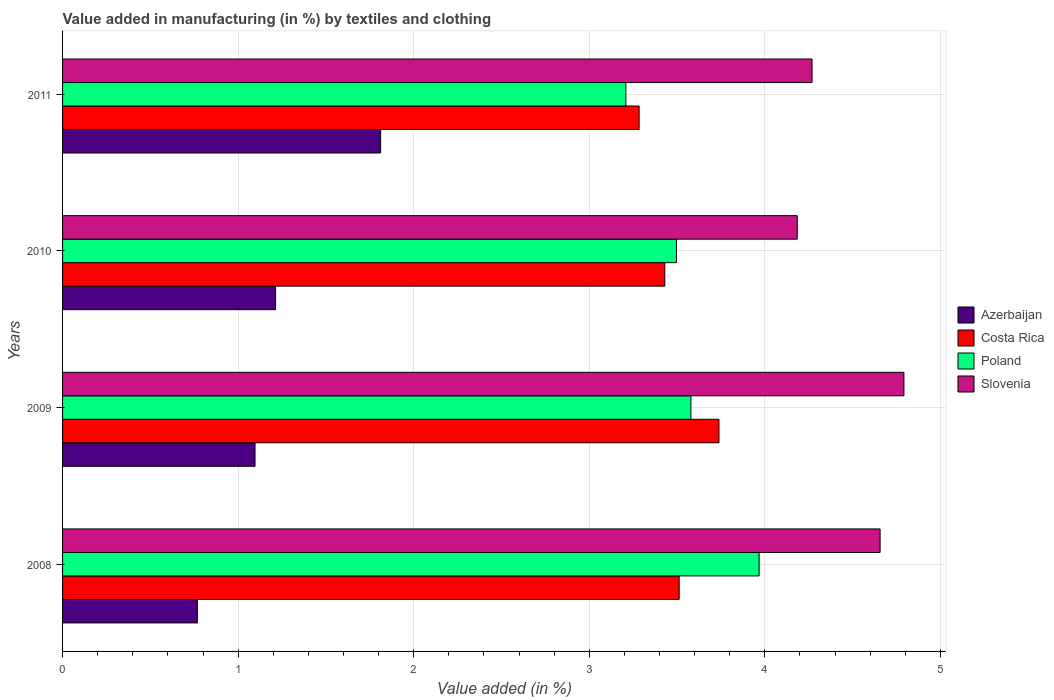How many different coloured bars are there?
Keep it short and to the point. 4. How many groups of bars are there?
Ensure brevity in your answer.  4. Are the number of bars on each tick of the Y-axis equal?
Provide a succinct answer. Yes. How many bars are there on the 4th tick from the bottom?
Offer a terse response. 4. What is the percentage of value added in manufacturing by textiles and clothing in Poland in 2008?
Your answer should be compact. 3.97. Across all years, what is the maximum percentage of value added in manufacturing by textiles and clothing in Costa Rica?
Your answer should be very brief. 3.74. Across all years, what is the minimum percentage of value added in manufacturing by textiles and clothing in Azerbaijan?
Your answer should be compact. 0.77. What is the total percentage of value added in manufacturing by textiles and clothing in Slovenia in the graph?
Provide a short and direct response. 17.9. What is the difference between the percentage of value added in manufacturing by textiles and clothing in Slovenia in 2009 and that in 2010?
Provide a succinct answer. 0.61. What is the difference between the percentage of value added in manufacturing by textiles and clothing in Slovenia in 2010 and the percentage of value added in manufacturing by textiles and clothing in Poland in 2009?
Provide a succinct answer. 0.61. What is the average percentage of value added in manufacturing by textiles and clothing in Costa Rica per year?
Offer a terse response. 3.49. In the year 2009, what is the difference between the percentage of value added in manufacturing by textiles and clothing in Costa Rica and percentage of value added in manufacturing by textiles and clothing in Azerbaijan?
Your answer should be very brief. 2.64. In how many years, is the percentage of value added in manufacturing by textiles and clothing in Slovenia greater than 1.4 %?
Make the answer very short. 4. What is the ratio of the percentage of value added in manufacturing by textiles and clothing in Poland in 2008 to that in 2010?
Offer a terse response. 1.13. What is the difference between the highest and the second highest percentage of value added in manufacturing by textiles and clothing in Slovenia?
Your answer should be compact. 0.14. What is the difference between the highest and the lowest percentage of value added in manufacturing by textiles and clothing in Costa Rica?
Keep it short and to the point. 0.45. Is the sum of the percentage of value added in manufacturing by textiles and clothing in Slovenia in 2009 and 2010 greater than the maximum percentage of value added in manufacturing by textiles and clothing in Costa Rica across all years?
Keep it short and to the point. Yes. Is it the case that in every year, the sum of the percentage of value added in manufacturing by textiles and clothing in Costa Rica and percentage of value added in manufacturing by textiles and clothing in Poland is greater than the sum of percentage of value added in manufacturing by textiles and clothing in Azerbaijan and percentage of value added in manufacturing by textiles and clothing in Slovenia?
Give a very brief answer. Yes. What does the 3rd bar from the top in 2008 represents?
Your answer should be very brief. Costa Rica. What does the 3rd bar from the bottom in 2010 represents?
Provide a short and direct response. Poland. How many years are there in the graph?
Make the answer very short. 4. Does the graph contain grids?
Provide a short and direct response. Yes. How are the legend labels stacked?
Make the answer very short. Vertical. What is the title of the graph?
Offer a very short reply. Value added in manufacturing (in %) by textiles and clothing. Does "Heavily indebted poor countries" appear as one of the legend labels in the graph?
Ensure brevity in your answer.  No. What is the label or title of the X-axis?
Make the answer very short. Value added (in %). What is the label or title of the Y-axis?
Give a very brief answer. Years. What is the Value added (in %) in Azerbaijan in 2008?
Provide a succinct answer. 0.77. What is the Value added (in %) in Costa Rica in 2008?
Your answer should be very brief. 3.51. What is the Value added (in %) in Poland in 2008?
Make the answer very short. 3.97. What is the Value added (in %) of Slovenia in 2008?
Provide a short and direct response. 4.66. What is the Value added (in %) of Azerbaijan in 2009?
Ensure brevity in your answer.  1.1. What is the Value added (in %) in Costa Rica in 2009?
Offer a terse response. 3.74. What is the Value added (in %) of Poland in 2009?
Offer a very short reply. 3.58. What is the Value added (in %) in Slovenia in 2009?
Your answer should be very brief. 4.79. What is the Value added (in %) in Azerbaijan in 2010?
Offer a terse response. 1.21. What is the Value added (in %) of Costa Rica in 2010?
Provide a short and direct response. 3.43. What is the Value added (in %) of Poland in 2010?
Make the answer very short. 3.5. What is the Value added (in %) in Slovenia in 2010?
Provide a succinct answer. 4.18. What is the Value added (in %) of Azerbaijan in 2011?
Make the answer very short. 1.81. What is the Value added (in %) of Costa Rica in 2011?
Make the answer very short. 3.28. What is the Value added (in %) of Poland in 2011?
Offer a very short reply. 3.21. What is the Value added (in %) in Slovenia in 2011?
Keep it short and to the point. 4.27. Across all years, what is the maximum Value added (in %) in Azerbaijan?
Offer a very short reply. 1.81. Across all years, what is the maximum Value added (in %) in Costa Rica?
Your response must be concise. 3.74. Across all years, what is the maximum Value added (in %) in Poland?
Keep it short and to the point. 3.97. Across all years, what is the maximum Value added (in %) of Slovenia?
Provide a succinct answer. 4.79. Across all years, what is the minimum Value added (in %) in Azerbaijan?
Offer a terse response. 0.77. Across all years, what is the minimum Value added (in %) in Costa Rica?
Provide a succinct answer. 3.28. Across all years, what is the minimum Value added (in %) of Poland?
Provide a short and direct response. 3.21. Across all years, what is the minimum Value added (in %) of Slovenia?
Ensure brevity in your answer.  4.18. What is the total Value added (in %) of Azerbaijan in the graph?
Make the answer very short. 4.89. What is the total Value added (in %) of Costa Rica in the graph?
Keep it short and to the point. 13.97. What is the total Value added (in %) of Poland in the graph?
Give a very brief answer. 14.25. What is the total Value added (in %) in Slovenia in the graph?
Offer a terse response. 17.9. What is the difference between the Value added (in %) in Azerbaijan in 2008 and that in 2009?
Keep it short and to the point. -0.33. What is the difference between the Value added (in %) of Costa Rica in 2008 and that in 2009?
Provide a succinct answer. -0.23. What is the difference between the Value added (in %) in Poland in 2008 and that in 2009?
Offer a very short reply. 0.39. What is the difference between the Value added (in %) of Slovenia in 2008 and that in 2009?
Ensure brevity in your answer.  -0.14. What is the difference between the Value added (in %) in Azerbaijan in 2008 and that in 2010?
Give a very brief answer. -0.45. What is the difference between the Value added (in %) of Costa Rica in 2008 and that in 2010?
Give a very brief answer. 0.08. What is the difference between the Value added (in %) of Poland in 2008 and that in 2010?
Provide a short and direct response. 0.47. What is the difference between the Value added (in %) in Slovenia in 2008 and that in 2010?
Provide a short and direct response. 0.47. What is the difference between the Value added (in %) in Azerbaijan in 2008 and that in 2011?
Ensure brevity in your answer.  -1.04. What is the difference between the Value added (in %) in Costa Rica in 2008 and that in 2011?
Give a very brief answer. 0.23. What is the difference between the Value added (in %) in Poland in 2008 and that in 2011?
Your response must be concise. 0.76. What is the difference between the Value added (in %) in Slovenia in 2008 and that in 2011?
Provide a short and direct response. 0.39. What is the difference between the Value added (in %) in Azerbaijan in 2009 and that in 2010?
Provide a succinct answer. -0.12. What is the difference between the Value added (in %) in Costa Rica in 2009 and that in 2010?
Offer a terse response. 0.31. What is the difference between the Value added (in %) of Poland in 2009 and that in 2010?
Make the answer very short. 0.08. What is the difference between the Value added (in %) in Slovenia in 2009 and that in 2010?
Provide a succinct answer. 0.61. What is the difference between the Value added (in %) in Azerbaijan in 2009 and that in 2011?
Your answer should be compact. -0.72. What is the difference between the Value added (in %) in Costa Rica in 2009 and that in 2011?
Offer a terse response. 0.45. What is the difference between the Value added (in %) in Poland in 2009 and that in 2011?
Keep it short and to the point. 0.37. What is the difference between the Value added (in %) of Slovenia in 2009 and that in 2011?
Offer a very short reply. 0.52. What is the difference between the Value added (in %) of Azerbaijan in 2010 and that in 2011?
Offer a very short reply. -0.6. What is the difference between the Value added (in %) of Costa Rica in 2010 and that in 2011?
Keep it short and to the point. 0.15. What is the difference between the Value added (in %) in Poland in 2010 and that in 2011?
Provide a short and direct response. 0.29. What is the difference between the Value added (in %) of Slovenia in 2010 and that in 2011?
Your answer should be very brief. -0.08. What is the difference between the Value added (in %) of Azerbaijan in 2008 and the Value added (in %) of Costa Rica in 2009?
Your answer should be compact. -2.97. What is the difference between the Value added (in %) in Azerbaijan in 2008 and the Value added (in %) in Poland in 2009?
Make the answer very short. -2.81. What is the difference between the Value added (in %) of Azerbaijan in 2008 and the Value added (in %) of Slovenia in 2009?
Make the answer very short. -4.02. What is the difference between the Value added (in %) of Costa Rica in 2008 and the Value added (in %) of Poland in 2009?
Ensure brevity in your answer.  -0.07. What is the difference between the Value added (in %) in Costa Rica in 2008 and the Value added (in %) in Slovenia in 2009?
Provide a succinct answer. -1.28. What is the difference between the Value added (in %) in Poland in 2008 and the Value added (in %) in Slovenia in 2009?
Your answer should be compact. -0.82. What is the difference between the Value added (in %) in Azerbaijan in 2008 and the Value added (in %) in Costa Rica in 2010?
Keep it short and to the point. -2.66. What is the difference between the Value added (in %) in Azerbaijan in 2008 and the Value added (in %) in Poland in 2010?
Keep it short and to the point. -2.73. What is the difference between the Value added (in %) in Azerbaijan in 2008 and the Value added (in %) in Slovenia in 2010?
Give a very brief answer. -3.42. What is the difference between the Value added (in %) of Costa Rica in 2008 and the Value added (in %) of Poland in 2010?
Make the answer very short. 0.02. What is the difference between the Value added (in %) of Costa Rica in 2008 and the Value added (in %) of Slovenia in 2010?
Offer a very short reply. -0.67. What is the difference between the Value added (in %) of Poland in 2008 and the Value added (in %) of Slovenia in 2010?
Provide a short and direct response. -0.22. What is the difference between the Value added (in %) in Azerbaijan in 2008 and the Value added (in %) in Costa Rica in 2011?
Keep it short and to the point. -2.52. What is the difference between the Value added (in %) in Azerbaijan in 2008 and the Value added (in %) in Poland in 2011?
Your answer should be very brief. -2.44. What is the difference between the Value added (in %) of Azerbaijan in 2008 and the Value added (in %) of Slovenia in 2011?
Your response must be concise. -3.5. What is the difference between the Value added (in %) in Costa Rica in 2008 and the Value added (in %) in Poland in 2011?
Give a very brief answer. 0.3. What is the difference between the Value added (in %) of Costa Rica in 2008 and the Value added (in %) of Slovenia in 2011?
Provide a succinct answer. -0.76. What is the difference between the Value added (in %) in Poland in 2008 and the Value added (in %) in Slovenia in 2011?
Keep it short and to the point. -0.3. What is the difference between the Value added (in %) of Azerbaijan in 2009 and the Value added (in %) of Costa Rica in 2010?
Keep it short and to the point. -2.33. What is the difference between the Value added (in %) of Azerbaijan in 2009 and the Value added (in %) of Poland in 2010?
Give a very brief answer. -2.4. What is the difference between the Value added (in %) in Azerbaijan in 2009 and the Value added (in %) in Slovenia in 2010?
Offer a very short reply. -3.09. What is the difference between the Value added (in %) in Costa Rica in 2009 and the Value added (in %) in Poland in 2010?
Provide a short and direct response. 0.24. What is the difference between the Value added (in %) in Costa Rica in 2009 and the Value added (in %) in Slovenia in 2010?
Provide a succinct answer. -0.45. What is the difference between the Value added (in %) in Poland in 2009 and the Value added (in %) in Slovenia in 2010?
Give a very brief answer. -0.61. What is the difference between the Value added (in %) in Azerbaijan in 2009 and the Value added (in %) in Costa Rica in 2011?
Keep it short and to the point. -2.19. What is the difference between the Value added (in %) of Azerbaijan in 2009 and the Value added (in %) of Poland in 2011?
Offer a terse response. -2.11. What is the difference between the Value added (in %) in Azerbaijan in 2009 and the Value added (in %) in Slovenia in 2011?
Provide a succinct answer. -3.17. What is the difference between the Value added (in %) in Costa Rica in 2009 and the Value added (in %) in Poland in 2011?
Your response must be concise. 0.53. What is the difference between the Value added (in %) in Costa Rica in 2009 and the Value added (in %) in Slovenia in 2011?
Your response must be concise. -0.53. What is the difference between the Value added (in %) in Poland in 2009 and the Value added (in %) in Slovenia in 2011?
Offer a very short reply. -0.69. What is the difference between the Value added (in %) of Azerbaijan in 2010 and the Value added (in %) of Costa Rica in 2011?
Your answer should be very brief. -2.07. What is the difference between the Value added (in %) in Azerbaijan in 2010 and the Value added (in %) in Poland in 2011?
Offer a terse response. -2. What is the difference between the Value added (in %) in Azerbaijan in 2010 and the Value added (in %) in Slovenia in 2011?
Give a very brief answer. -3.06. What is the difference between the Value added (in %) in Costa Rica in 2010 and the Value added (in %) in Poland in 2011?
Your response must be concise. 0.22. What is the difference between the Value added (in %) of Costa Rica in 2010 and the Value added (in %) of Slovenia in 2011?
Give a very brief answer. -0.84. What is the difference between the Value added (in %) in Poland in 2010 and the Value added (in %) in Slovenia in 2011?
Your response must be concise. -0.77. What is the average Value added (in %) of Azerbaijan per year?
Give a very brief answer. 1.22. What is the average Value added (in %) of Costa Rica per year?
Make the answer very short. 3.49. What is the average Value added (in %) in Poland per year?
Your response must be concise. 3.56. What is the average Value added (in %) in Slovenia per year?
Make the answer very short. 4.48. In the year 2008, what is the difference between the Value added (in %) of Azerbaijan and Value added (in %) of Costa Rica?
Give a very brief answer. -2.74. In the year 2008, what is the difference between the Value added (in %) in Azerbaijan and Value added (in %) in Poland?
Offer a terse response. -3.2. In the year 2008, what is the difference between the Value added (in %) in Azerbaijan and Value added (in %) in Slovenia?
Offer a very short reply. -3.89. In the year 2008, what is the difference between the Value added (in %) of Costa Rica and Value added (in %) of Poland?
Provide a succinct answer. -0.46. In the year 2008, what is the difference between the Value added (in %) of Costa Rica and Value added (in %) of Slovenia?
Make the answer very short. -1.14. In the year 2008, what is the difference between the Value added (in %) in Poland and Value added (in %) in Slovenia?
Give a very brief answer. -0.69. In the year 2009, what is the difference between the Value added (in %) of Azerbaijan and Value added (in %) of Costa Rica?
Ensure brevity in your answer.  -2.64. In the year 2009, what is the difference between the Value added (in %) in Azerbaijan and Value added (in %) in Poland?
Offer a very short reply. -2.48. In the year 2009, what is the difference between the Value added (in %) of Azerbaijan and Value added (in %) of Slovenia?
Your response must be concise. -3.7. In the year 2009, what is the difference between the Value added (in %) of Costa Rica and Value added (in %) of Poland?
Offer a terse response. 0.16. In the year 2009, what is the difference between the Value added (in %) in Costa Rica and Value added (in %) in Slovenia?
Provide a short and direct response. -1.05. In the year 2009, what is the difference between the Value added (in %) in Poland and Value added (in %) in Slovenia?
Keep it short and to the point. -1.21. In the year 2010, what is the difference between the Value added (in %) of Azerbaijan and Value added (in %) of Costa Rica?
Keep it short and to the point. -2.22. In the year 2010, what is the difference between the Value added (in %) of Azerbaijan and Value added (in %) of Poland?
Your answer should be very brief. -2.28. In the year 2010, what is the difference between the Value added (in %) of Azerbaijan and Value added (in %) of Slovenia?
Your answer should be very brief. -2.97. In the year 2010, what is the difference between the Value added (in %) in Costa Rica and Value added (in %) in Poland?
Your response must be concise. -0.07. In the year 2010, what is the difference between the Value added (in %) of Costa Rica and Value added (in %) of Slovenia?
Make the answer very short. -0.75. In the year 2010, what is the difference between the Value added (in %) in Poland and Value added (in %) in Slovenia?
Provide a succinct answer. -0.69. In the year 2011, what is the difference between the Value added (in %) in Azerbaijan and Value added (in %) in Costa Rica?
Your response must be concise. -1.47. In the year 2011, what is the difference between the Value added (in %) in Azerbaijan and Value added (in %) in Poland?
Keep it short and to the point. -1.4. In the year 2011, what is the difference between the Value added (in %) of Azerbaijan and Value added (in %) of Slovenia?
Offer a terse response. -2.46. In the year 2011, what is the difference between the Value added (in %) in Costa Rica and Value added (in %) in Poland?
Keep it short and to the point. 0.08. In the year 2011, what is the difference between the Value added (in %) of Costa Rica and Value added (in %) of Slovenia?
Your answer should be very brief. -0.98. In the year 2011, what is the difference between the Value added (in %) in Poland and Value added (in %) in Slovenia?
Make the answer very short. -1.06. What is the ratio of the Value added (in %) in Azerbaijan in 2008 to that in 2009?
Your response must be concise. 0.7. What is the ratio of the Value added (in %) of Costa Rica in 2008 to that in 2009?
Offer a terse response. 0.94. What is the ratio of the Value added (in %) in Poland in 2008 to that in 2009?
Make the answer very short. 1.11. What is the ratio of the Value added (in %) of Slovenia in 2008 to that in 2009?
Provide a short and direct response. 0.97. What is the ratio of the Value added (in %) of Azerbaijan in 2008 to that in 2010?
Keep it short and to the point. 0.63. What is the ratio of the Value added (in %) of Costa Rica in 2008 to that in 2010?
Keep it short and to the point. 1.02. What is the ratio of the Value added (in %) in Poland in 2008 to that in 2010?
Your answer should be compact. 1.13. What is the ratio of the Value added (in %) of Slovenia in 2008 to that in 2010?
Offer a terse response. 1.11. What is the ratio of the Value added (in %) in Azerbaijan in 2008 to that in 2011?
Keep it short and to the point. 0.42. What is the ratio of the Value added (in %) of Costa Rica in 2008 to that in 2011?
Ensure brevity in your answer.  1.07. What is the ratio of the Value added (in %) in Poland in 2008 to that in 2011?
Offer a very short reply. 1.24. What is the ratio of the Value added (in %) of Slovenia in 2008 to that in 2011?
Your answer should be compact. 1.09. What is the ratio of the Value added (in %) of Azerbaijan in 2009 to that in 2010?
Offer a terse response. 0.9. What is the ratio of the Value added (in %) of Costa Rica in 2009 to that in 2010?
Keep it short and to the point. 1.09. What is the ratio of the Value added (in %) of Poland in 2009 to that in 2010?
Provide a succinct answer. 1.02. What is the ratio of the Value added (in %) in Slovenia in 2009 to that in 2010?
Provide a succinct answer. 1.15. What is the ratio of the Value added (in %) in Azerbaijan in 2009 to that in 2011?
Offer a very short reply. 0.61. What is the ratio of the Value added (in %) in Costa Rica in 2009 to that in 2011?
Your answer should be compact. 1.14. What is the ratio of the Value added (in %) of Poland in 2009 to that in 2011?
Offer a terse response. 1.12. What is the ratio of the Value added (in %) of Slovenia in 2009 to that in 2011?
Offer a terse response. 1.12. What is the ratio of the Value added (in %) in Azerbaijan in 2010 to that in 2011?
Offer a terse response. 0.67. What is the ratio of the Value added (in %) in Costa Rica in 2010 to that in 2011?
Your response must be concise. 1.04. What is the ratio of the Value added (in %) of Poland in 2010 to that in 2011?
Give a very brief answer. 1.09. What is the ratio of the Value added (in %) of Slovenia in 2010 to that in 2011?
Ensure brevity in your answer.  0.98. What is the difference between the highest and the second highest Value added (in %) in Azerbaijan?
Your answer should be compact. 0.6. What is the difference between the highest and the second highest Value added (in %) of Costa Rica?
Keep it short and to the point. 0.23. What is the difference between the highest and the second highest Value added (in %) of Poland?
Provide a succinct answer. 0.39. What is the difference between the highest and the second highest Value added (in %) in Slovenia?
Your answer should be compact. 0.14. What is the difference between the highest and the lowest Value added (in %) in Azerbaijan?
Keep it short and to the point. 1.04. What is the difference between the highest and the lowest Value added (in %) in Costa Rica?
Provide a short and direct response. 0.45. What is the difference between the highest and the lowest Value added (in %) of Poland?
Provide a succinct answer. 0.76. What is the difference between the highest and the lowest Value added (in %) of Slovenia?
Provide a short and direct response. 0.61. 